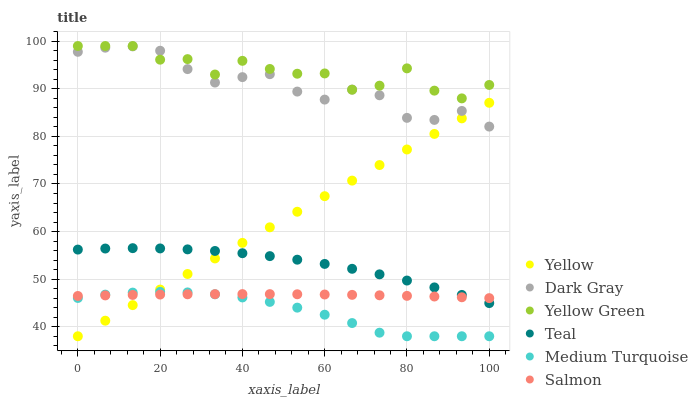Does Medium Turquoise have the minimum area under the curve?
Answer yes or no. Yes. Does Yellow Green have the maximum area under the curve?
Answer yes or no. Yes. Does Salmon have the minimum area under the curve?
Answer yes or no. No. Does Salmon have the maximum area under the curve?
Answer yes or no. No. Is Yellow the smoothest?
Answer yes or no. Yes. Is Yellow Green the roughest?
Answer yes or no. Yes. Is Salmon the smoothest?
Answer yes or no. No. Is Salmon the roughest?
Answer yes or no. No. Does Yellow have the lowest value?
Answer yes or no. Yes. Does Salmon have the lowest value?
Answer yes or no. No. Does Yellow Green have the highest value?
Answer yes or no. Yes. Does Yellow have the highest value?
Answer yes or no. No. Is Yellow less than Yellow Green?
Answer yes or no. Yes. Is Yellow Green greater than Salmon?
Answer yes or no. Yes. Does Yellow Green intersect Dark Gray?
Answer yes or no. Yes. Is Yellow Green less than Dark Gray?
Answer yes or no. No. Is Yellow Green greater than Dark Gray?
Answer yes or no. No. Does Yellow intersect Yellow Green?
Answer yes or no. No. 